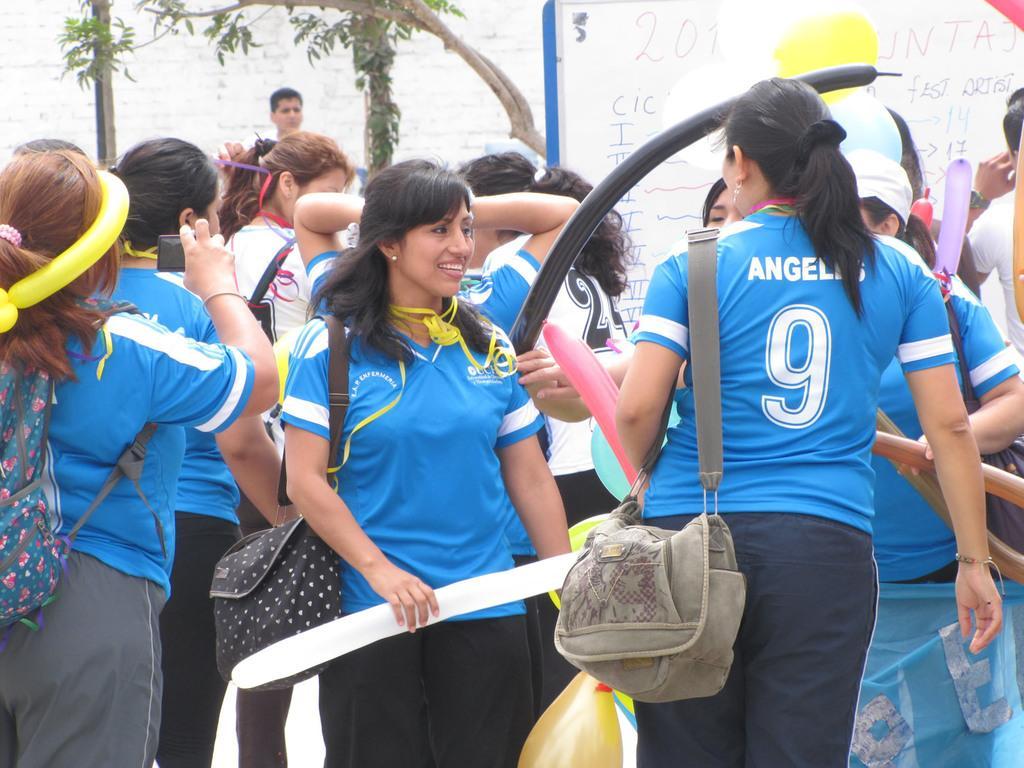How would you summarize this image in a sentence or two? In this image, we can see a group of people are standing. They wear a t-shirts and pants. And they are holding bags. Here we can see backpack. The left side of the image ,we can see woman is holding a camera. The center of the image, the woman is smiling. We can see her lips are open. We can see balloons here. Background, there is a tree and man also we can see. Here we can see a board white color. 